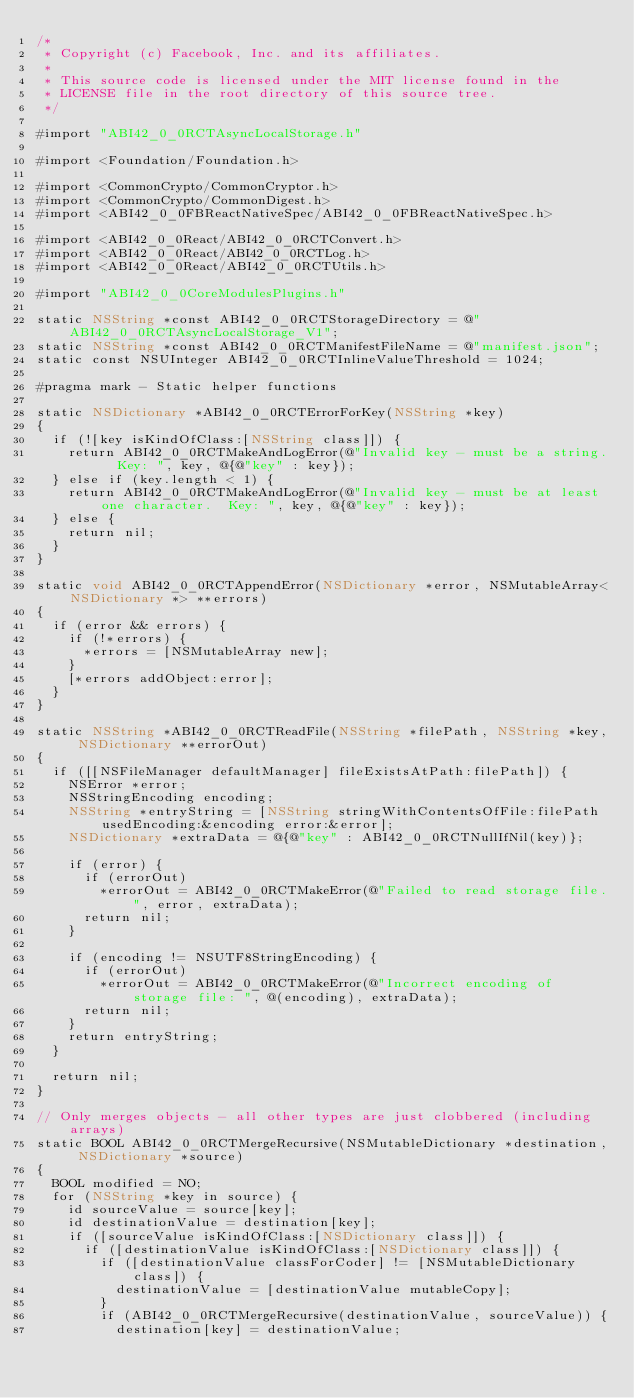<code> <loc_0><loc_0><loc_500><loc_500><_ObjectiveC_>/*
 * Copyright (c) Facebook, Inc. and its affiliates.
 *
 * This source code is licensed under the MIT license found in the
 * LICENSE file in the root directory of this source tree.
 */

#import "ABI42_0_0RCTAsyncLocalStorage.h"

#import <Foundation/Foundation.h>

#import <CommonCrypto/CommonCryptor.h>
#import <CommonCrypto/CommonDigest.h>
#import <ABI42_0_0FBReactNativeSpec/ABI42_0_0FBReactNativeSpec.h>

#import <ABI42_0_0React/ABI42_0_0RCTConvert.h>
#import <ABI42_0_0React/ABI42_0_0RCTLog.h>
#import <ABI42_0_0React/ABI42_0_0RCTUtils.h>

#import "ABI42_0_0CoreModulesPlugins.h"

static NSString *const ABI42_0_0RCTStorageDirectory = @"ABI42_0_0RCTAsyncLocalStorage_V1";
static NSString *const ABI42_0_0RCTManifestFileName = @"manifest.json";
static const NSUInteger ABI42_0_0RCTInlineValueThreshold = 1024;

#pragma mark - Static helper functions

static NSDictionary *ABI42_0_0RCTErrorForKey(NSString *key)
{
  if (![key isKindOfClass:[NSString class]]) {
    return ABI42_0_0RCTMakeAndLogError(@"Invalid key - must be a string.  Key: ", key, @{@"key" : key});
  } else if (key.length < 1) {
    return ABI42_0_0RCTMakeAndLogError(@"Invalid key - must be at least one character.  Key: ", key, @{@"key" : key});
  } else {
    return nil;
  }
}

static void ABI42_0_0RCTAppendError(NSDictionary *error, NSMutableArray<NSDictionary *> **errors)
{
  if (error && errors) {
    if (!*errors) {
      *errors = [NSMutableArray new];
    }
    [*errors addObject:error];
  }
}

static NSString *ABI42_0_0RCTReadFile(NSString *filePath, NSString *key, NSDictionary **errorOut)
{
  if ([[NSFileManager defaultManager] fileExistsAtPath:filePath]) {
    NSError *error;
    NSStringEncoding encoding;
    NSString *entryString = [NSString stringWithContentsOfFile:filePath usedEncoding:&encoding error:&error];
    NSDictionary *extraData = @{@"key" : ABI42_0_0RCTNullIfNil(key)};

    if (error) {
      if (errorOut)
        *errorOut = ABI42_0_0RCTMakeError(@"Failed to read storage file.", error, extraData);
      return nil;
    }

    if (encoding != NSUTF8StringEncoding) {
      if (errorOut)
        *errorOut = ABI42_0_0RCTMakeError(@"Incorrect encoding of storage file: ", @(encoding), extraData);
      return nil;
    }
    return entryString;
  }

  return nil;
}

// Only merges objects - all other types are just clobbered (including arrays)
static BOOL ABI42_0_0RCTMergeRecursive(NSMutableDictionary *destination, NSDictionary *source)
{
  BOOL modified = NO;
  for (NSString *key in source) {
    id sourceValue = source[key];
    id destinationValue = destination[key];
    if ([sourceValue isKindOfClass:[NSDictionary class]]) {
      if ([destinationValue isKindOfClass:[NSDictionary class]]) {
        if ([destinationValue classForCoder] != [NSMutableDictionary class]) {
          destinationValue = [destinationValue mutableCopy];
        }
        if (ABI42_0_0RCTMergeRecursive(destinationValue, sourceValue)) {
          destination[key] = destinationValue;</code> 